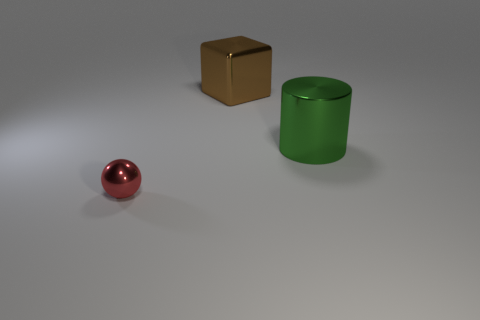Add 1 shiny objects. How many objects exist? 4 Subtract all yellow spheres. How many yellow cubes are left? 0 Subtract all green blocks. Subtract all tiny things. How many objects are left? 2 Add 1 large green cylinders. How many large green cylinders are left? 2 Add 2 small blue metallic cubes. How many small blue metallic cubes exist? 2 Subtract 0 gray blocks. How many objects are left? 3 